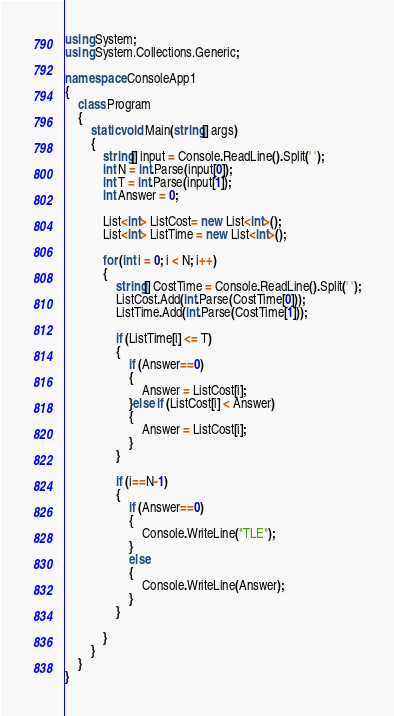Convert code to text. <code><loc_0><loc_0><loc_500><loc_500><_C#_>using System;
using System.Collections.Generic;

namespace ConsoleApp1
{
    class Program
    {
        static void Main(string[] args)
        {
            string[] input = Console.ReadLine().Split(' ');
            int N = int.Parse(input[0]);
            int T = int.Parse(input[1]);
            int Answer = 0;

            List<int> ListCost= new List<int>();
            List<int> ListTime = new List<int>();

            for (int i = 0; i < N; i++)
            {
                string[] CostTime = Console.ReadLine().Split(' ');
                ListCost.Add(int.Parse(CostTime[0]));
                ListTime.Add(int.Parse(CostTime[1]));

                if (ListTime[i] <= T)
                {
                    if (Answer==0)
                    {
                        Answer = ListCost[i];
                    }else if (ListCost[i] < Answer)
                    {
                        Answer = ListCost[i];
                    }
                }

                if (i==N-1)
                {
                    if (Answer==0)
                    {
                        Console.WriteLine("TLE");
                    }
                    else
                    {
                        Console.WriteLine(Answer);
                    }
                }

            }
        }
    }
}
</code> 